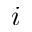<formula> <loc_0><loc_0><loc_500><loc_500>i</formula> 